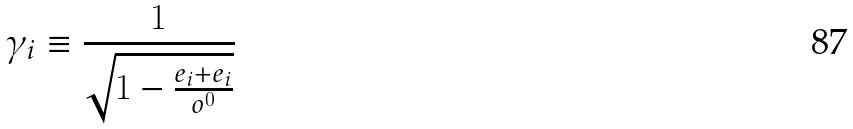<formula> <loc_0><loc_0><loc_500><loc_500>\gamma _ { i } \equiv \frac { 1 } { \sqrt { 1 - \frac { e _ { i } + e _ { i } } { o ^ { 0 } } } }</formula> 